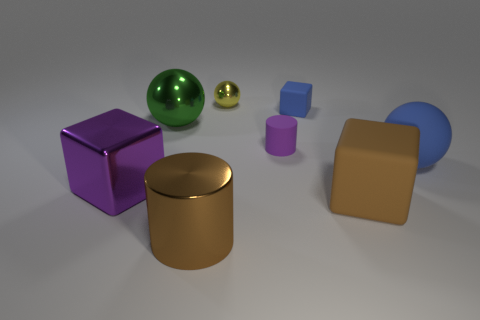Are there any objects right of the matte block on the right side of the cube that is behind the small purple matte thing? Yes, to the right of the matte block, which is also to the right side of the cube, there is a golden cylindrical object with a reflective surface. 